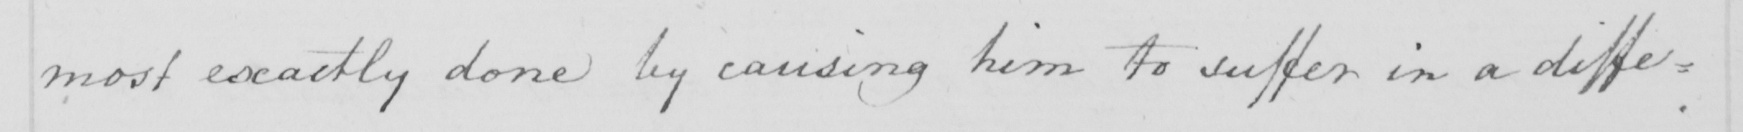Transcribe the text shown in this historical manuscript line. most exactly done by causing him to suffer in a diffe= 